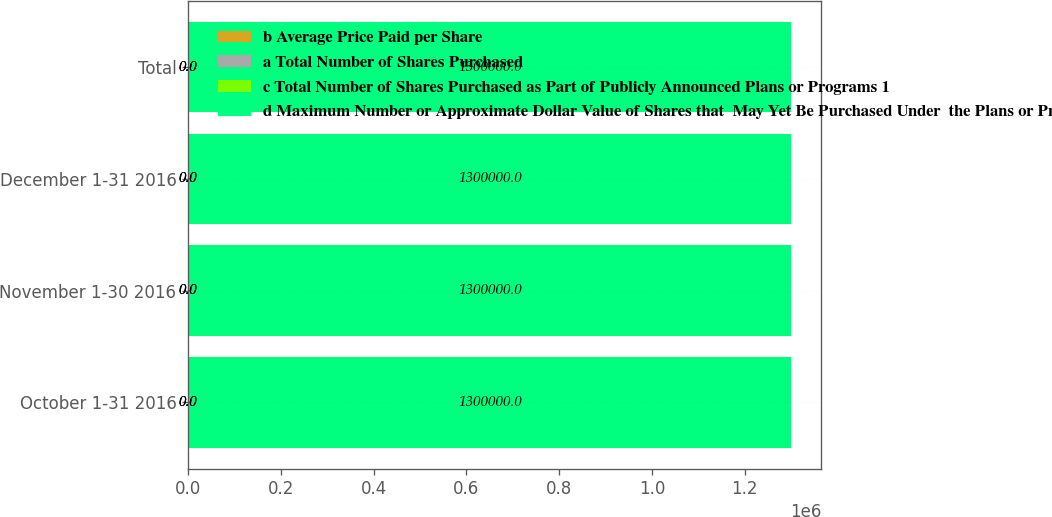<chart> <loc_0><loc_0><loc_500><loc_500><stacked_bar_chart><ecel><fcel>October 1-31 2016<fcel>November 1-30 2016<fcel>December 1-31 2016<fcel>Total<nl><fcel>b Average Price Paid per Share<fcel>0<fcel>0<fcel>0<fcel>0<nl><fcel>a Total Number of Shares Purchased<fcel>0<fcel>0<fcel>0<fcel>0<nl><fcel>c Total Number of Shares Purchased as Part of Publicly Announced Plans or Programs 1<fcel>0<fcel>0<fcel>0<fcel>0<nl><fcel>d Maximum Number or Approximate Dollar Value of Shares that  May Yet Be Purchased Under  the Plans or Programs 1<fcel>1.3e+06<fcel>1.3e+06<fcel>1.3e+06<fcel>1.3e+06<nl></chart> 